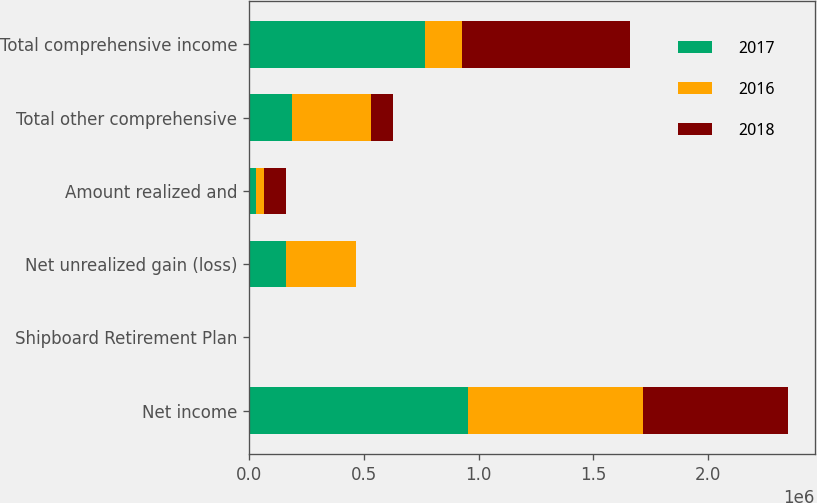<chart> <loc_0><loc_0><loc_500><loc_500><stacked_bar_chart><ecel><fcel>Net income<fcel>Shipboard Retirement Plan<fcel>Net unrealized gain (loss)<fcel>Amount realized and<fcel>Total other comprehensive<fcel>Total comprehensive income<nl><fcel>2017<fcel>954843<fcel>2697<fcel>161214<fcel>30096<fcel>188613<fcel>766230<nl><fcel>2016<fcel>759872<fcel>40<fcel>304684<fcel>36795<fcel>341439<fcel>161214<nl><fcel>2018<fcel>633085<fcel>497<fcel>1711<fcel>95969<fcel>98177<fcel>731262<nl></chart> 